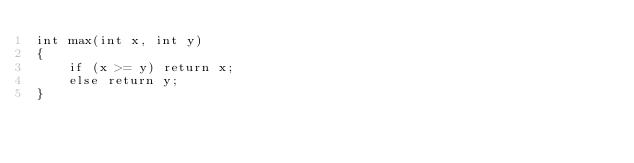<code> <loc_0><loc_0><loc_500><loc_500><_C_>int max(int x, int y)
{
    if (x >= y) return x;
    else return y;
}</code> 